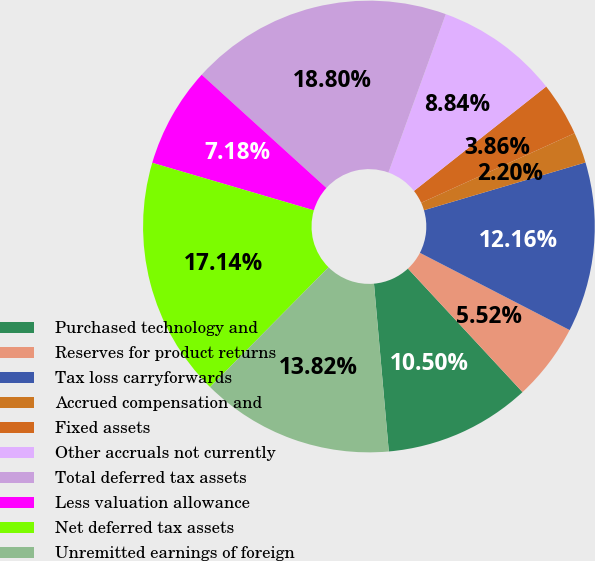<chart> <loc_0><loc_0><loc_500><loc_500><pie_chart><fcel>Purchased technology and<fcel>Reserves for product returns<fcel>Tax loss carryforwards<fcel>Accrued compensation and<fcel>Fixed assets<fcel>Other accruals not currently<fcel>Total deferred tax assets<fcel>Less valuation allowance<fcel>Net deferred tax assets<fcel>Unremitted earnings of foreign<nl><fcel>10.5%<fcel>5.52%<fcel>12.16%<fcel>2.2%<fcel>3.86%<fcel>8.84%<fcel>18.8%<fcel>7.18%<fcel>17.14%<fcel>13.82%<nl></chart> 